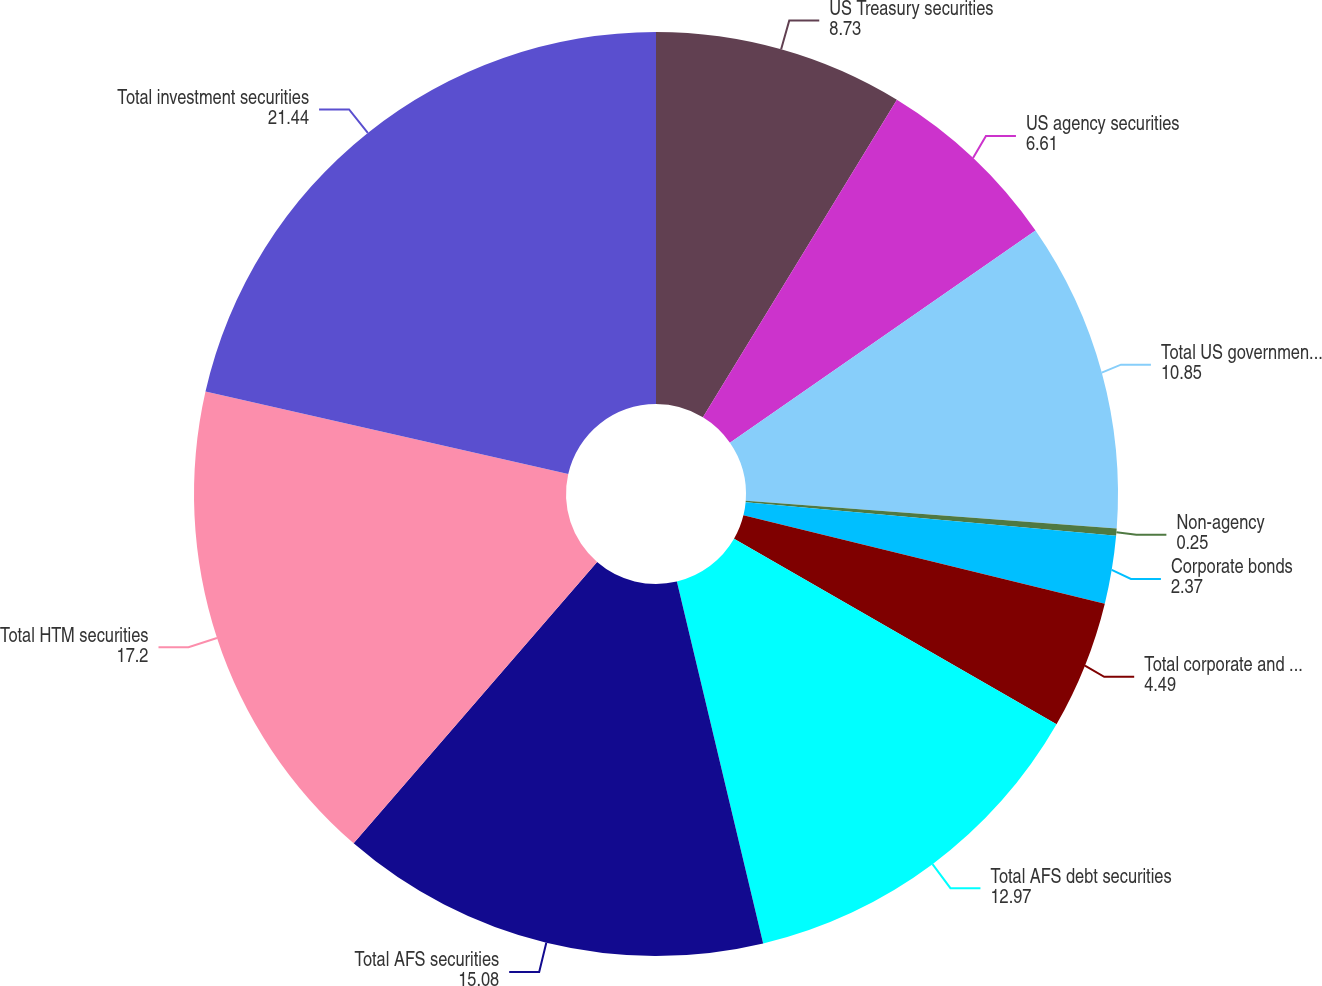<chart> <loc_0><loc_0><loc_500><loc_500><pie_chart><fcel>US Treasury securities<fcel>US agency securities<fcel>Total US government and agency<fcel>Non-agency<fcel>Corporate bonds<fcel>Total corporate and other debt<fcel>Total AFS debt securities<fcel>Total AFS securities<fcel>Total HTM securities<fcel>Total investment securities<nl><fcel>8.73%<fcel>6.61%<fcel>10.85%<fcel>0.25%<fcel>2.37%<fcel>4.49%<fcel>12.97%<fcel>15.08%<fcel>17.2%<fcel>21.44%<nl></chart> 